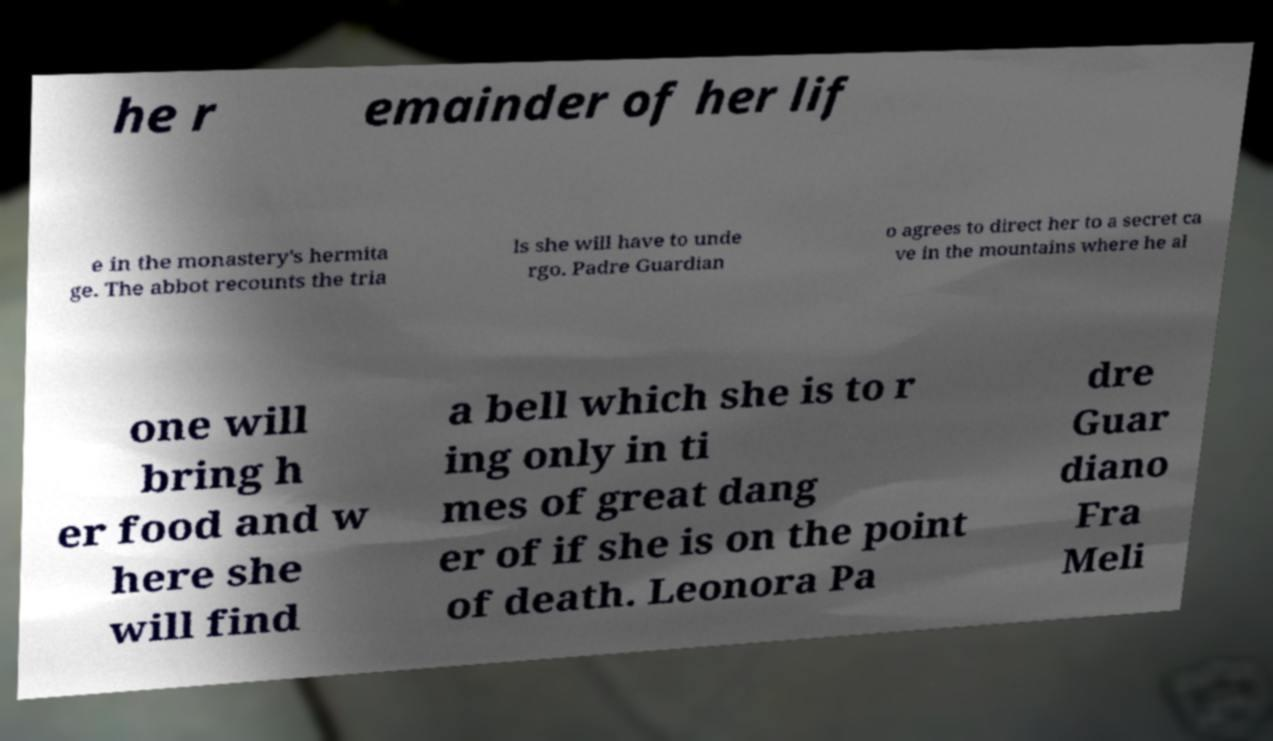I need the written content from this picture converted into text. Can you do that? he r emainder of her lif e in the monastery's hermita ge. The abbot recounts the tria ls she will have to unde rgo. Padre Guardian o agrees to direct her to a secret ca ve in the mountains where he al one will bring h er food and w here she will find a bell which she is to r ing only in ti mes of great dang er of if she is on the point of death. Leonora Pa dre Guar diano Fra Meli 